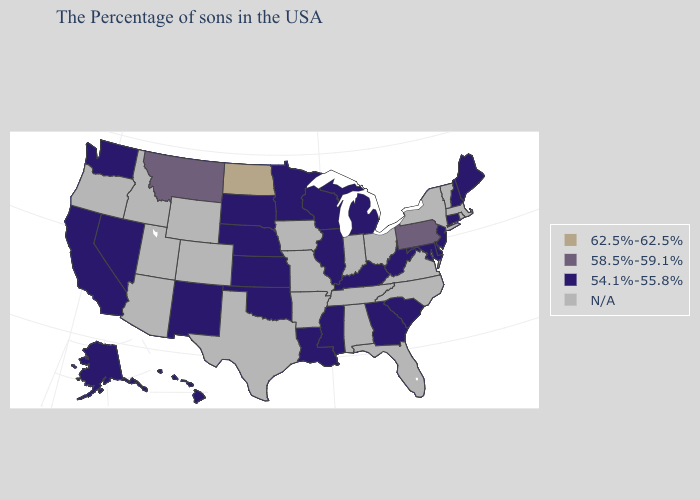What is the highest value in the West ?
Keep it brief. 58.5%-59.1%. Name the states that have a value in the range 58.5%-59.1%?
Concise answer only. Pennsylvania, Montana. Which states have the lowest value in the South?
Answer briefly. Delaware, Maryland, South Carolina, West Virginia, Georgia, Kentucky, Mississippi, Louisiana, Oklahoma. What is the lowest value in the MidWest?
Be succinct. 54.1%-55.8%. Name the states that have a value in the range N/A?
Answer briefly. Massachusetts, Rhode Island, Vermont, New York, Virginia, North Carolina, Ohio, Florida, Indiana, Alabama, Tennessee, Missouri, Arkansas, Iowa, Texas, Wyoming, Colorado, Utah, Arizona, Idaho, Oregon. Does Montana have the highest value in the USA?
Concise answer only. No. Which states hav the highest value in the Northeast?
Be succinct. Pennsylvania. What is the lowest value in the USA?
Short answer required. 54.1%-55.8%. Name the states that have a value in the range 62.5%-62.5%?
Concise answer only. North Dakota. What is the value of North Dakota?
Be succinct. 62.5%-62.5%. Name the states that have a value in the range N/A?
Concise answer only. Massachusetts, Rhode Island, Vermont, New York, Virginia, North Carolina, Ohio, Florida, Indiana, Alabama, Tennessee, Missouri, Arkansas, Iowa, Texas, Wyoming, Colorado, Utah, Arizona, Idaho, Oregon. 